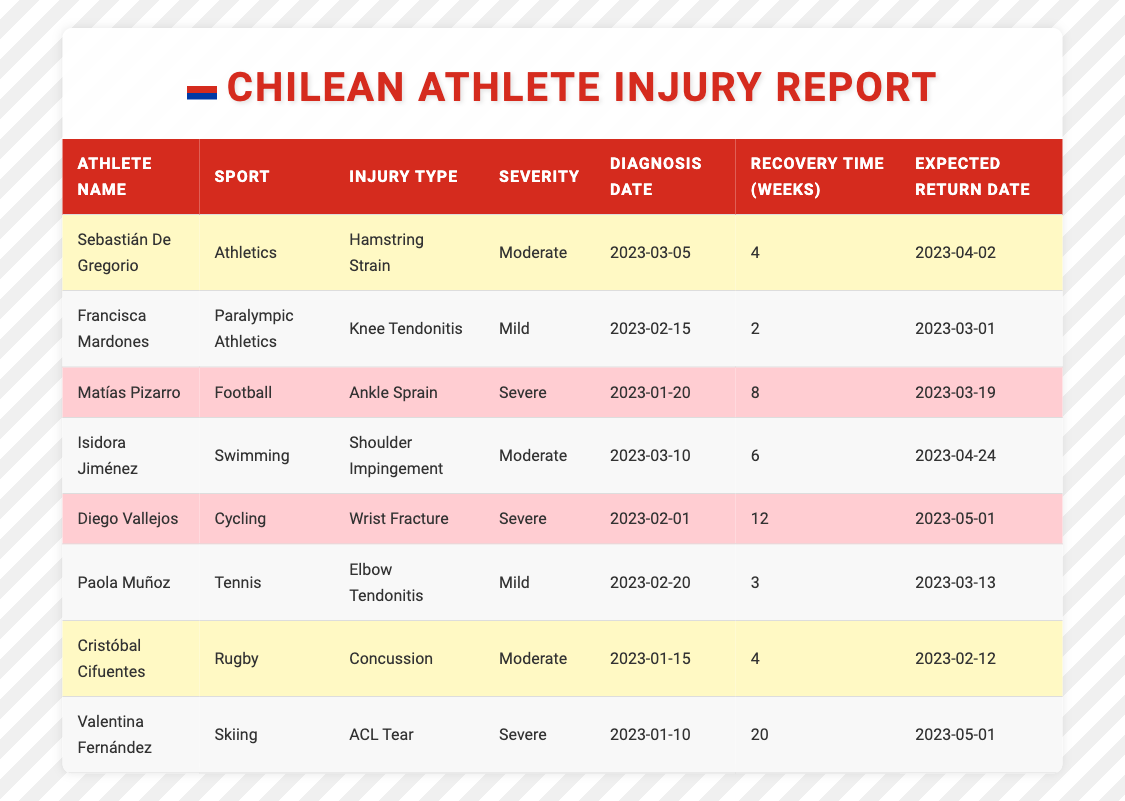What is the injury type for Sebastián De Gregorio? From the table, Sebastián De Gregorio has a "Hamstring Strain" listed under the Injury Type column.
Answer: Hamstring Strain How many weeks of recovery time are needed for Matías Pizarro? In the table, Matías Pizarro has a recovery time of 8 weeks noted in the Recovery Time column.
Answer: 8 weeks Which athlete is expected to return the latest? Valentina Fernández is expected to return on "2023-05-01", which is the latest date compared to all other athletes' expected return dates.
Answer: Valentina Fernández Is Diego Vallejos' injury classified as severe? The table indicates Diego Vallejos' injury type is a "Wrist Fracture", which is categorized as severe, thus the answer is yes.
Answer: Yes Which sport has the most severe injuries listed in the report? Upon reviewing the table, both Football, Cycling, and Skiing have severe injuries (Ankle Sprain, Wrist Fracture, ACL Tear), but since Cycling has two severe injuries, it has the most severe injury classification.
Answer: Cycling What is the total recovery time for athletes in contact sports like Rugby and Football? For Rugby, Cristóbal Cifuentes has a recovery time of 4 weeks, and for Football, Matías Pizarro has a recovery time of 8 weeks. Summing these: 4 + 8 = 12 weeks.
Answer: 12 weeks How many athletes are expected to return by March 2023? The athletes expected to return by March 2023 are Francisca Mardones (March 1), Paola Muñoz (March 13), and Matías Pizarro (March 19). There are a total of three athletes.
Answer: 3 athletes What injury type has the shortest recovery time? The shortest recovery time is for Francisca Mardones, with only 2 weeks of recovery time for "Knee Tendonitis", making it the injury type with the shortest recovery time.
Answer: Knee Tendonitis Are there any athletes who are expected to return on the same date? Yes, both Diego Vallejos and Valentina Fernández are expected to return on "2023-05-01", indicating they share the same expected return date.
Answer: Yes What is the average recovery time for athletes with mild injuries? The mild injuries are from Francisca Mardones (2 weeks) and Paola Muñoz (3 weeks). The average recovery time is calculated as (2 + 3) / 2 = 2.5 weeks.
Answer: 2.5 weeks 